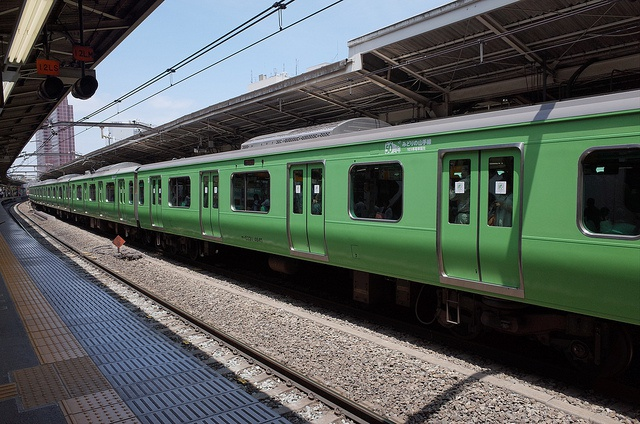Describe the objects in this image and their specific colors. I can see a train in black, green, darkgreen, and teal tones in this image. 